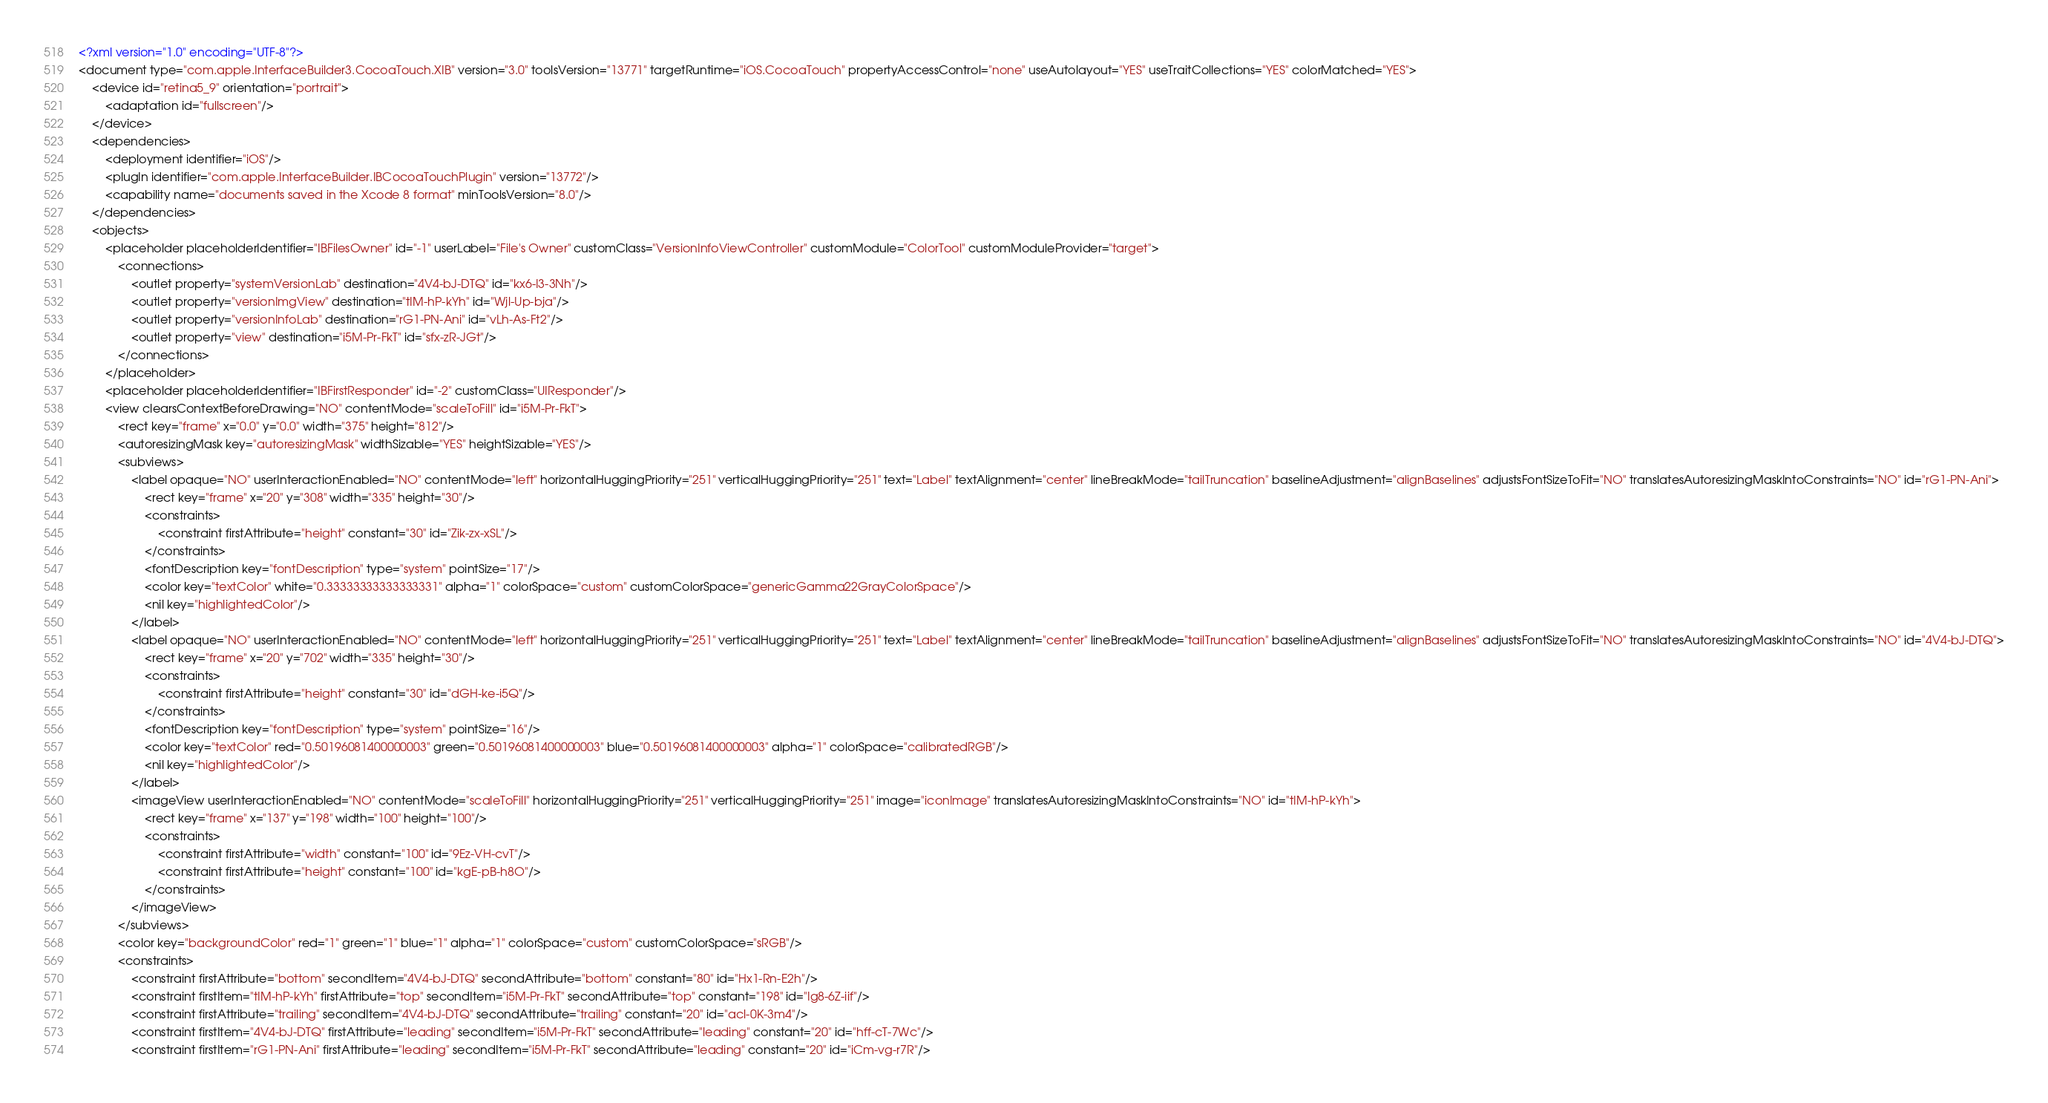<code> <loc_0><loc_0><loc_500><loc_500><_XML_><?xml version="1.0" encoding="UTF-8"?>
<document type="com.apple.InterfaceBuilder3.CocoaTouch.XIB" version="3.0" toolsVersion="13771" targetRuntime="iOS.CocoaTouch" propertyAccessControl="none" useAutolayout="YES" useTraitCollections="YES" colorMatched="YES">
    <device id="retina5_9" orientation="portrait">
        <adaptation id="fullscreen"/>
    </device>
    <dependencies>
        <deployment identifier="iOS"/>
        <plugIn identifier="com.apple.InterfaceBuilder.IBCocoaTouchPlugin" version="13772"/>
        <capability name="documents saved in the Xcode 8 format" minToolsVersion="8.0"/>
    </dependencies>
    <objects>
        <placeholder placeholderIdentifier="IBFilesOwner" id="-1" userLabel="File's Owner" customClass="VersionInfoViewController" customModule="ColorTool" customModuleProvider="target">
            <connections>
                <outlet property="systemVersionLab" destination="4V4-bJ-DTQ" id="kx6-I3-3Nh"/>
                <outlet property="versionImgView" destination="tIM-hP-kYh" id="Wjl-Up-bja"/>
                <outlet property="versionInfoLab" destination="rG1-PN-Ani" id="vLh-As-Ft2"/>
                <outlet property="view" destination="i5M-Pr-FkT" id="sfx-zR-JGt"/>
            </connections>
        </placeholder>
        <placeholder placeholderIdentifier="IBFirstResponder" id="-2" customClass="UIResponder"/>
        <view clearsContextBeforeDrawing="NO" contentMode="scaleToFill" id="i5M-Pr-FkT">
            <rect key="frame" x="0.0" y="0.0" width="375" height="812"/>
            <autoresizingMask key="autoresizingMask" widthSizable="YES" heightSizable="YES"/>
            <subviews>
                <label opaque="NO" userInteractionEnabled="NO" contentMode="left" horizontalHuggingPriority="251" verticalHuggingPriority="251" text="Label" textAlignment="center" lineBreakMode="tailTruncation" baselineAdjustment="alignBaselines" adjustsFontSizeToFit="NO" translatesAutoresizingMaskIntoConstraints="NO" id="rG1-PN-Ani">
                    <rect key="frame" x="20" y="308" width="335" height="30"/>
                    <constraints>
                        <constraint firstAttribute="height" constant="30" id="Zik-zx-xSL"/>
                    </constraints>
                    <fontDescription key="fontDescription" type="system" pointSize="17"/>
                    <color key="textColor" white="0.33333333333333331" alpha="1" colorSpace="custom" customColorSpace="genericGamma22GrayColorSpace"/>
                    <nil key="highlightedColor"/>
                </label>
                <label opaque="NO" userInteractionEnabled="NO" contentMode="left" horizontalHuggingPriority="251" verticalHuggingPriority="251" text="Label" textAlignment="center" lineBreakMode="tailTruncation" baselineAdjustment="alignBaselines" adjustsFontSizeToFit="NO" translatesAutoresizingMaskIntoConstraints="NO" id="4V4-bJ-DTQ">
                    <rect key="frame" x="20" y="702" width="335" height="30"/>
                    <constraints>
                        <constraint firstAttribute="height" constant="30" id="dGH-ke-i5Q"/>
                    </constraints>
                    <fontDescription key="fontDescription" type="system" pointSize="16"/>
                    <color key="textColor" red="0.50196081400000003" green="0.50196081400000003" blue="0.50196081400000003" alpha="1" colorSpace="calibratedRGB"/>
                    <nil key="highlightedColor"/>
                </label>
                <imageView userInteractionEnabled="NO" contentMode="scaleToFill" horizontalHuggingPriority="251" verticalHuggingPriority="251" image="iconImage" translatesAutoresizingMaskIntoConstraints="NO" id="tIM-hP-kYh">
                    <rect key="frame" x="137" y="198" width="100" height="100"/>
                    <constraints>
                        <constraint firstAttribute="width" constant="100" id="9Ez-VH-cvT"/>
                        <constraint firstAttribute="height" constant="100" id="kgE-pB-h8O"/>
                    </constraints>
                </imageView>
            </subviews>
            <color key="backgroundColor" red="1" green="1" blue="1" alpha="1" colorSpace="custom" customColorSpace="sRGB"/>
            <constraints>
                <constraint firstAttribute="bottom" secondItem="4V4-bJ-DTQ" secondAttribute="bottom" constant="80" id="Hx1-Rn-E2h"/>
                <constraint firstItem="tIM-hP-kYh" firstAttribute="top" secondItem="i5M-Pr-FkT" secondAttribute="top" constant="198" id="Ig8-6Z-iif"/>
                <constraint firstAttribute="trailing" secondItem="4V4-bJ-DTQ" secondAttribute="trailing" constant="20" id="acl-0K-3m4"/>
                <constraint firstItem="4V4-bJ-DTQ" firstAttribute="leading" secondItem="i5M-Pr-FkT" secondAttribute="leading" constant="20" id="hff-cT-7Wc"/>
                <constraint firstItem="rG1-PN-Ani" firstAttribute="leading" secondItem="i5M-Pr-FkT" secondAttribute="leading" constant="20" id="iCm-vg-r7R"/></code> 